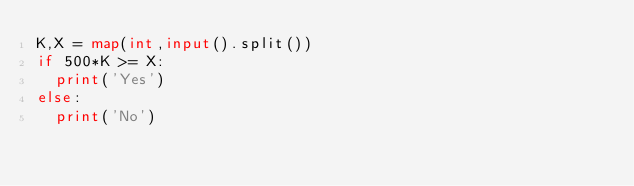<code> <loc_0><loc_0><loc_500><loc_500><_Python_>K,X = map(int,input().split())
if 500*K >= X:
  print('Yes')
else:
  print('No')</code> 